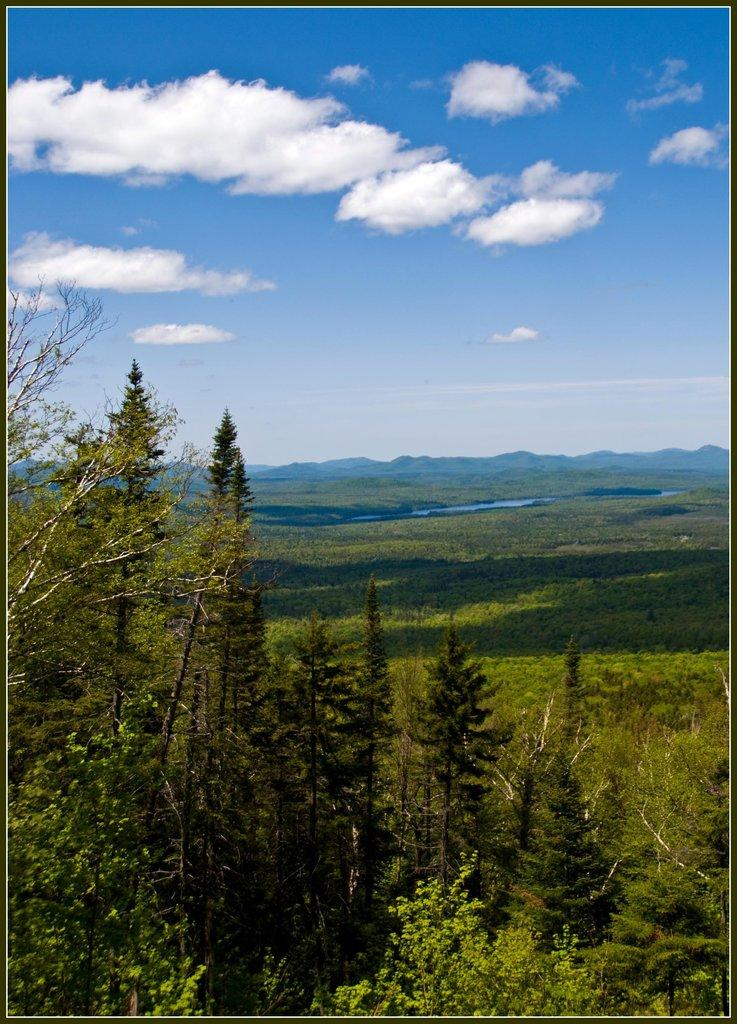What type of vegetation can be seen in the image? There are plants and trees in the image. What can be seen in the background of the image? The sky is visible in the background of the image, along with additional plants. What type of cough medicine is visible in the image? There is no cough medicine present in the image; it features plants, trees, and the sky. What is the taste of the plants in the image? Plants do not have a taste, as they are not edible in the context of the image. 